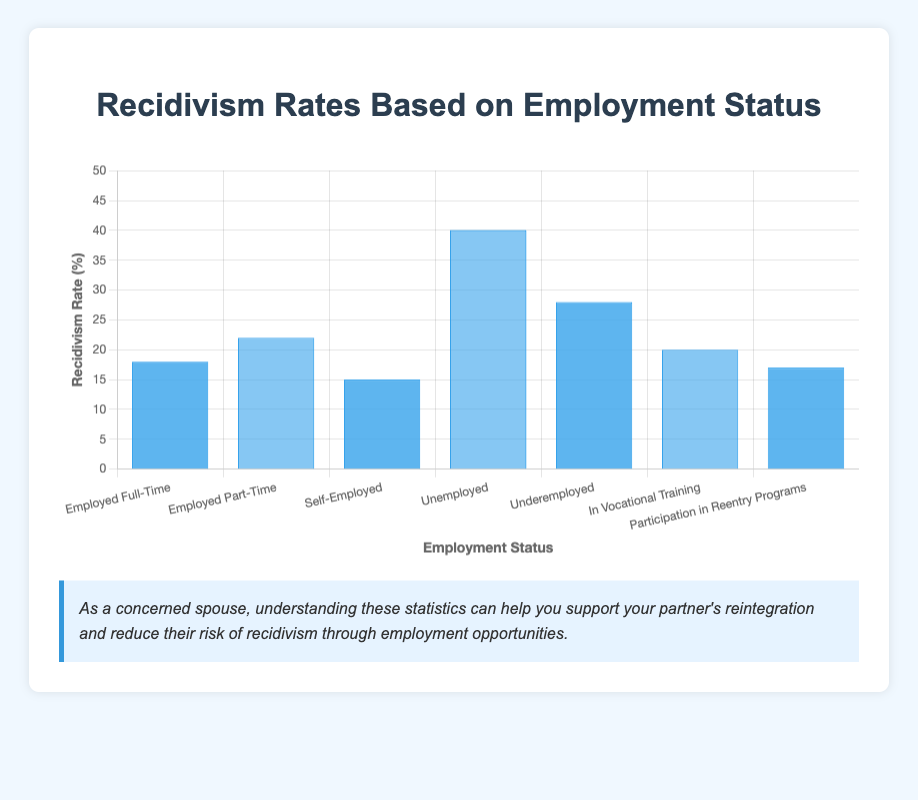Which employment status has the highest recidivism rate? The "Unemployed" status has the highest recidivism rate as the bar for "Unemployed" is the tallest, standing at 40%.
Answer: Unemployed What is the difference in recidivism rate between "Employed Full-Time" and "Unemployed"? The recidivism rate for "Unemployed" is 40% and for "Employed Full-Time" is 18%. The difference is 40 - 18 = 22%.
Answer: 22% Which employment status has the lowest recidivism rate? The "Participation in Reentry Programs" status has the lowest recidivism rate as the bar for this status is the shortest, standing at 17%.
Answer: Participation in Reentry Programs What is the average recidivism rate for "Employed Part-Time" and "Self-Employed"? The rate for "Employed Part-Time" is 22% and for "Self-Employed" is 15%. The average is (22 + 15) / 2 = 18.5%.
Answer: 18.5% Are the recidivism rates for "In Vocational Training" and "Employed Full-Time" closer to each other compared to their rates with "Underemployed"? The rates for "In Vocational Training" and "Employed Full-Time" are 20% and 18%, respectively, which are closer with a difference of 2%. The rates for "In Vocational Training" and "Underemployed" are 20% and 28%, respectively, with a difference of 8%. The rates for "Employed Full-Time" and "Underemployed" are 18% and 28%, respectively, with a difference of 10%. Thus, "In Vocational Training" and "Employed Full-Time" are closer to each other.
Answer: Yes How much higher is the recidivism rate for "Underemployed" compared to "Self-Employed"? The rate for "Underemployed" is 28% and for "Self-Employed" is 15%. The difference is 28 - 15 = 13%.
Answer: 13% What is the median recidivism rate among all employment statuses listed? The sorted recidivism rates are 15, 17, 18, 20, 22, 28, 40. The median is the middle value, which is 20%.
Answer: 20% How does the recidivism rate for "In Vocational Training" compare to the overall average recidivism rate? The recidivism rates are 18, 22, 15, 40, 28, 20, 17. The sum is 160, and the average is 160/7 ≈ 22.86%. "In Vocational Training" has a rate of 20%, which is lower than the overall average.
Answer: Lower Which employment status shows a surprising recidivism rate given the efforts to reintegrate former inmates? "Participation in Reentry Programs" shows a low recidivism rate of 17%, which is relatively low given the efforts, demonstrating success in reducing recidivism.
Answer: Participation in Reentry Programs 